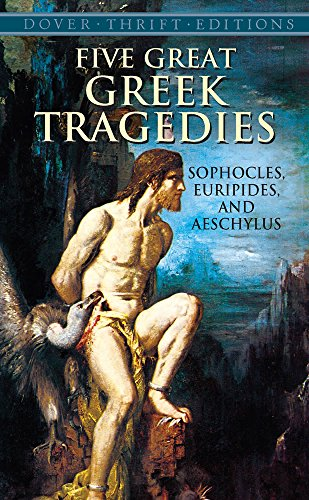What is the title of this book? The title of this book visible on the cover is 'Five Great Greek Tragedies', and it's a Dover Thrift Edition. 